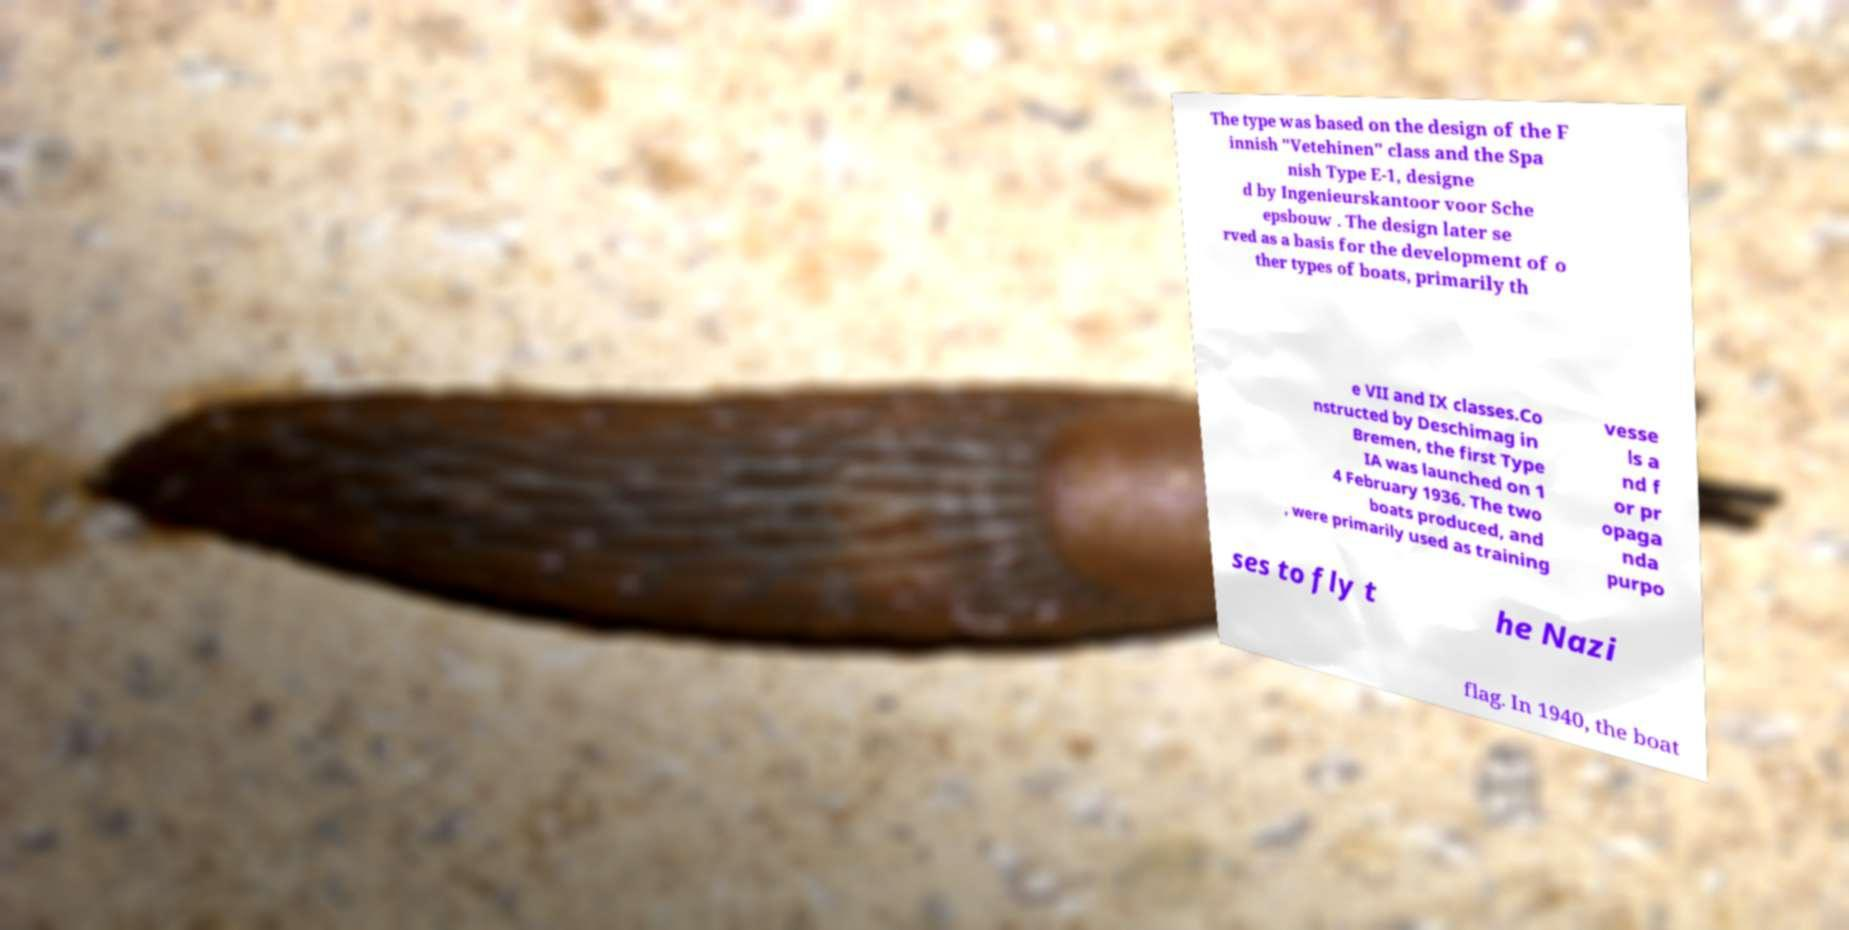Please read and relay the text visible in this image. What does it say? The type was based on the design of the F innish "Vetehinen" class and the Spa nish Type E-1, designe d by Ingenieurskantoor voor Sche epsbouw . The design later se rved as a basis for the development of o ther types of boats, primarily th e VII and IX classes.Co nstructed by Deschimag in Bremen, the first Type IA was launched on 1 4 February 1936. The two boats produced, and , were primarily used as training vesse ls a nd f or pr opaga nda purpo ses to fly t he Nazi flag. In 1940, the boat 